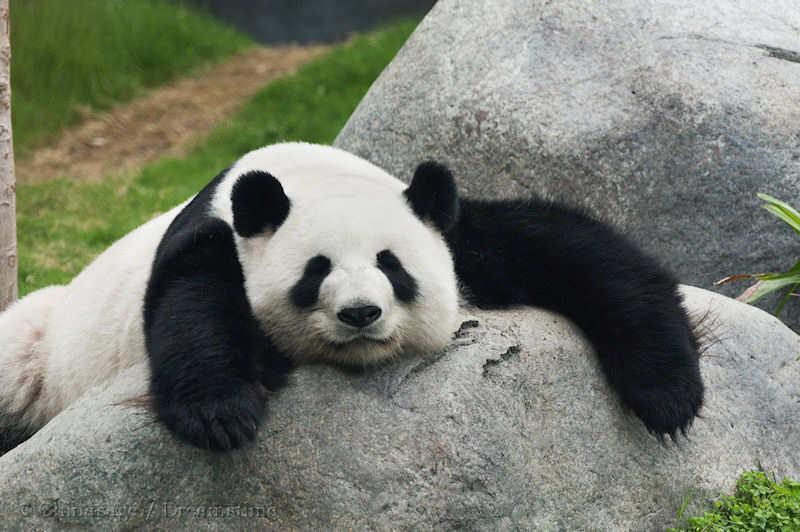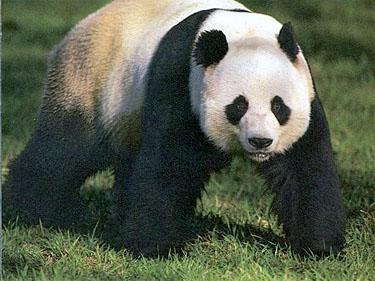The first image is the image on the left, the second image is the image on the right. Given the left and right images, does the statement "At least one of the images has a big panda with a much smaller panda." hold true? Answer yes or no. No. The first image is the image on the left, the second image is the image on the right. Evaluate the accuracy of this statement regarding the images: "One image has a baby panda being held while on top of an adult panda that is on its back.". Is it true? Answer yes or no. No. 